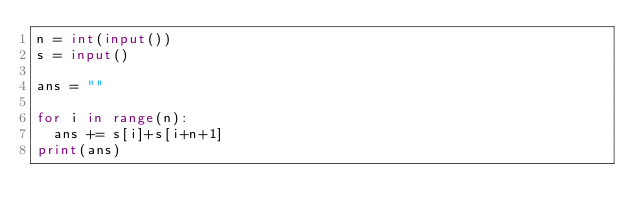Convert code to text. <code><loc_0><loc_0><loc_500><loc_500><_Python_>n = int(input())
s = input()

ans = ""

for i in range(n):
  ans += s[i]+s[i+n+1]
print(ans)
</code> 